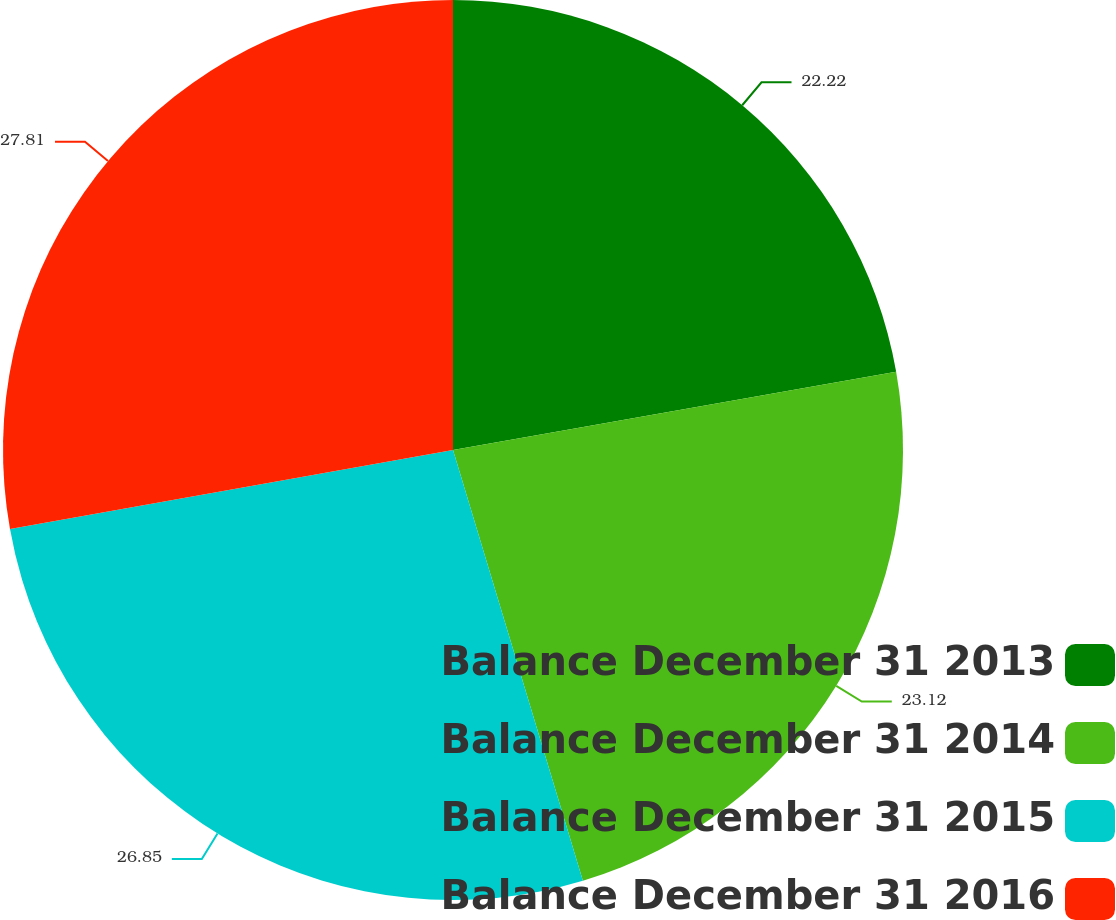Convert chart. <chart><loc_0><loc_0><loc_500><loc_500><pie_chart><fcel>Balance December 31 2013<fcel>Balance December 31 2014<fcel>Balance December 31 2015<fcel>Balance December 31 2016<nl><fcel>22.22%<fcel>23.12%<fcel>26.85%<fcel>27.81%<nl></chart> 